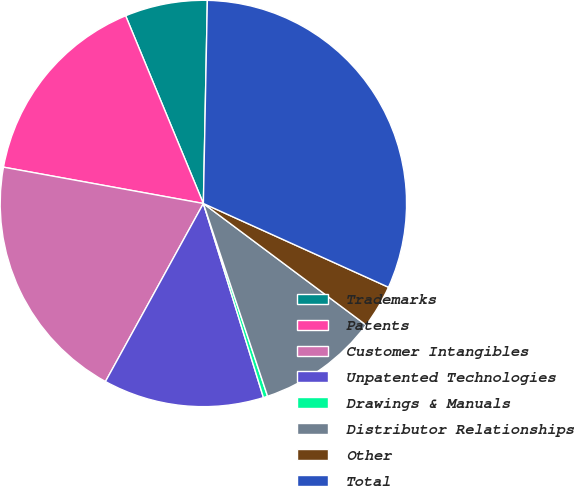Convert chart. <chart><loc_0><loc_0><loc_500><loc_500><pie_chart><fcel>Trademarks<fcel>Patents<fcel>Customer Intangibles<fcel>Unpatented Technologies<fcel>Drawings & Manuals<fcel>Distributor Relationships<fcel>Other<fcel>Total<nl><fcel>6.56%<fcel>15.89%<fcel>19.86%<fcel>12.78%<fcel>0.34%<fcel>9.67%<fcel>3.45%<fcel>31.45%<nl></chart> 